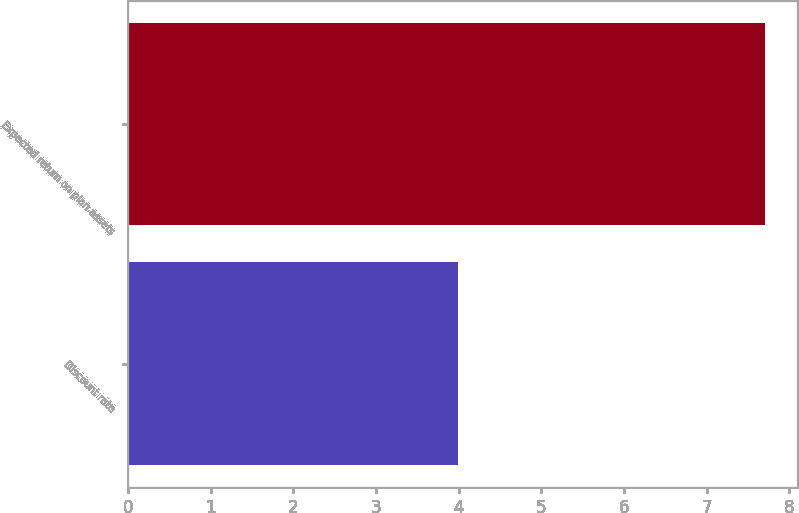<chart> <loc_0><loc_0><loc_500><loc_500><bar_chart><fcel>Discount rate<fcel>Expected return on plan assets<nl><fcel>3.99<fcel>7.7<nl></chart> 